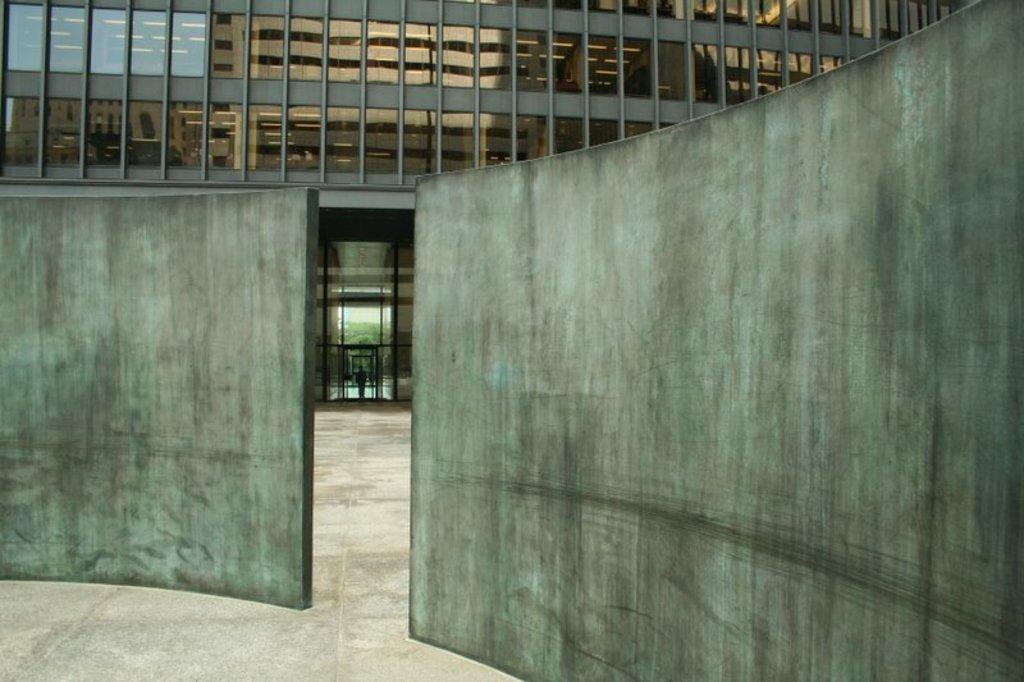Please provide a concise description of this image. Front we can see wall. This is building with glass windows. On this glass windows there is a reflection of another building. 